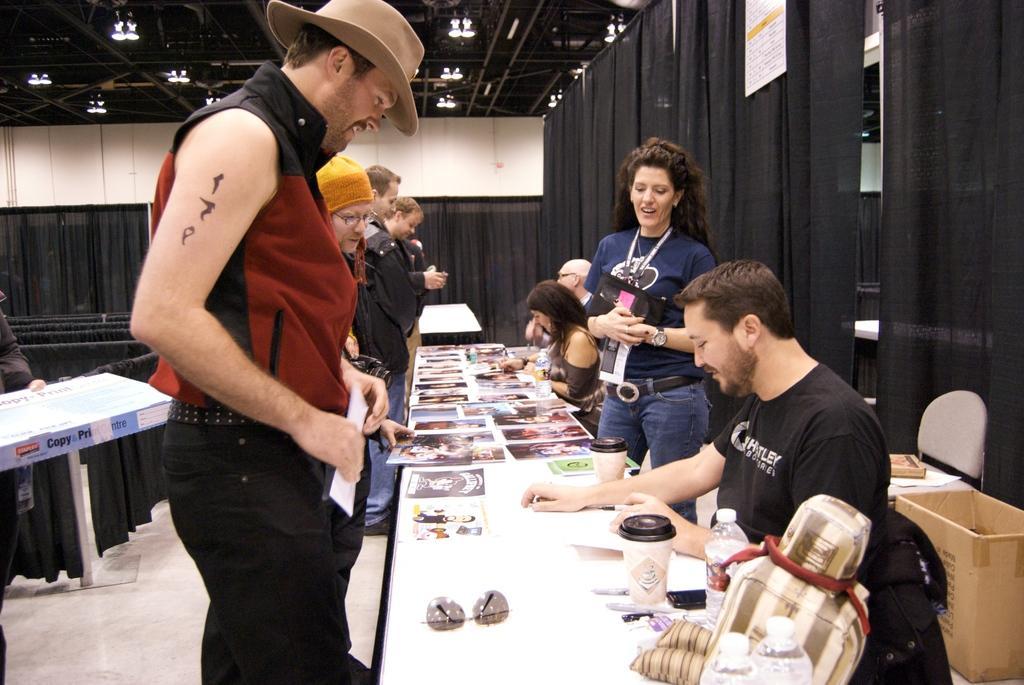Please provide a concise description of this image. In this picture there is a table in the center of the image, on which there are posters and there are people around it, there is black color curtain in the background area of the image. 